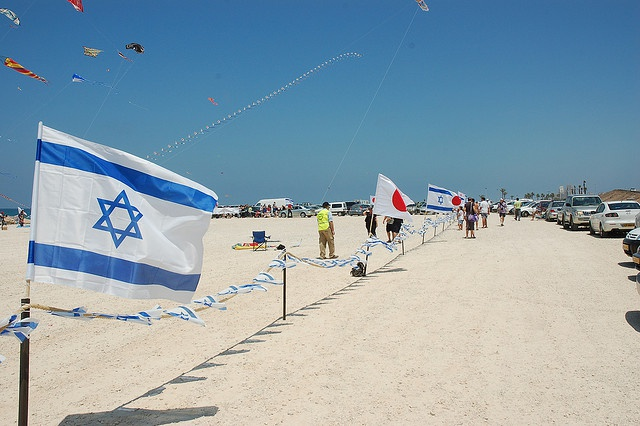Describe the objects in this image and their specific colors. I can see car in blue, darkgray, black, lightgray, and gray tones, car in blue, black, gray, darkgray, and teal tones, kite in blue, gray, and darkgray tones, people in blue, gray, olive, khaki, and tan tones, and car in blue, black, lightgray, and gray tones in this image. 